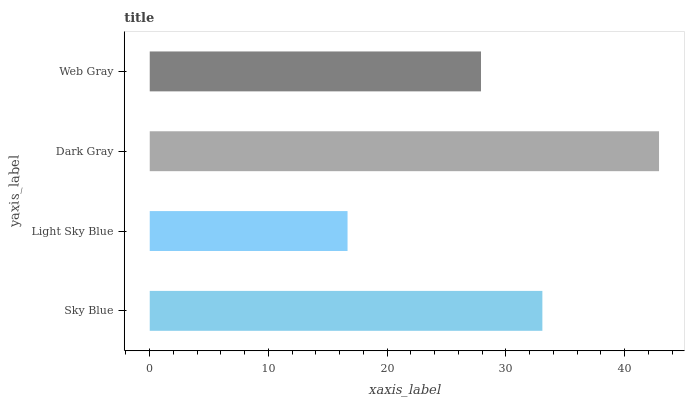Is Light Sky Blue the minimum?
Answer yes or no. Yes. Is Dark Gray the maximum?
Answer yes or no. Yes. Is Dark Gray the minimum?
Answer yes or no. No. Is Light Sky Blue the maximum?
Answer yes or no. No. Is Dark Gray greater than Light Sky Blue?
Answer yes or no. Yes. Is Light Sky Blue less than Dark Gray?
Answer yes or no. Yes. Is Light Sky Blue greater than Dark Gray?
Answer yes or no. No. Is Dark Gray less than Light Sky Blue?
Answer yes or no. No. Is Sky Blue the high median?
Answer yes or no. Yes. Is Web Gray the low median?
Answer yes or no. Yes. Is Light Sky Blue the high median?
Answer yes or no. No. Is Light Sky Blue the low median?
Answer yes or no. No. 